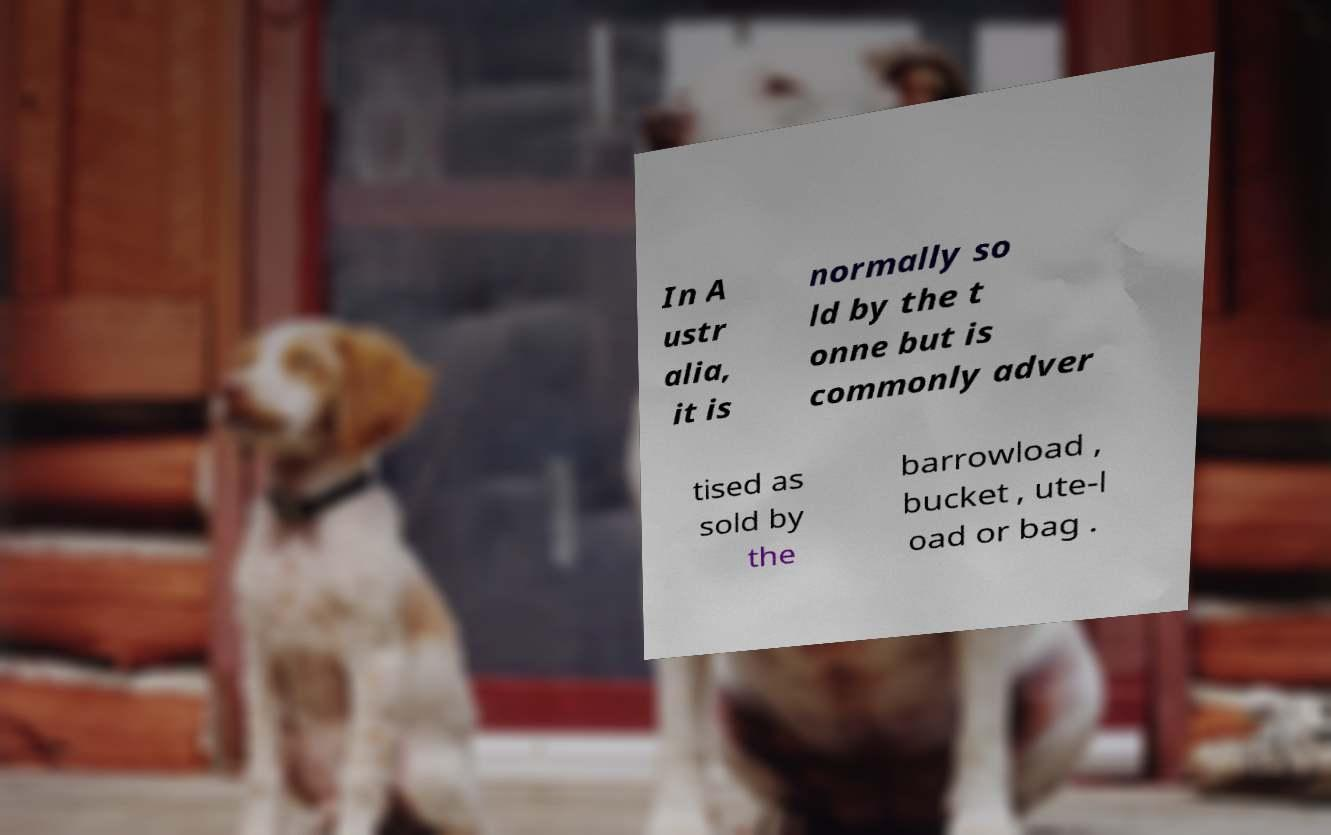There's text embedded in this image that I need extracted. Can you transcribe it verbatim? In A ustr alia, it is normally so ld by the t onne but is commonly adver tised as sold by the barrowload , bucket , ute-l oad or bag . 